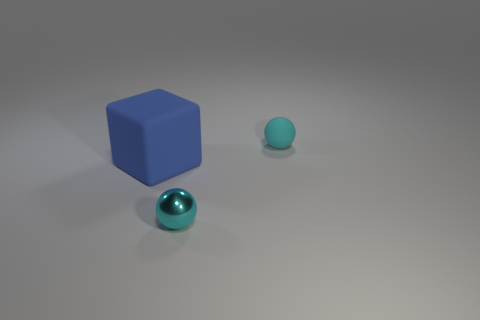Are the materials of the objects significant in any way? Material choice can greatly influence perception. The matte finish of the balls suggests an understated beauty, while the blue cube's solid appearance provides a visual anchor, offering contrast and balance to the composition. How might the positioning of these objects serve a practical study in physics or design? The deliberate placement of these objects could serve as an exercise in spatial geometry, exploring how different shapes and distances interact within a given volume. This setup might also be used to study the interaction of light and shadow on various colors and textures. 